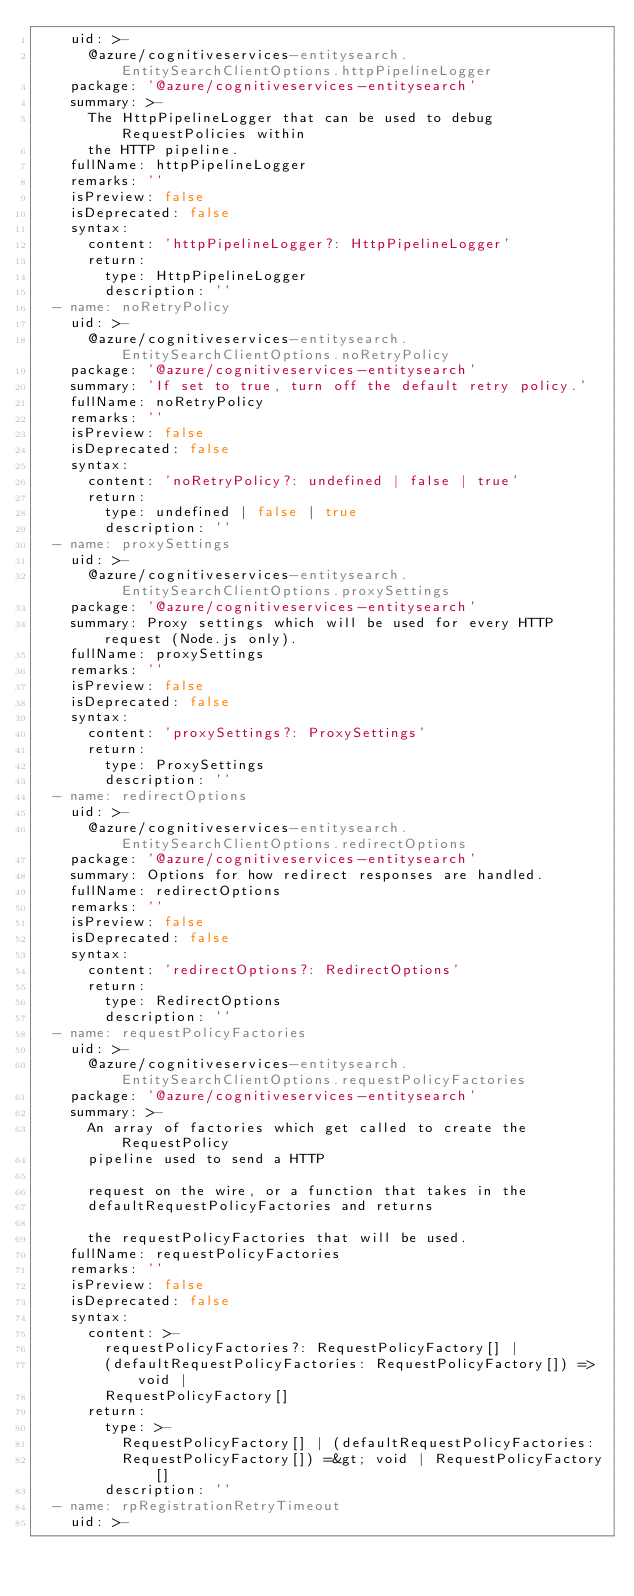<code> <loc_0><loc_0><loc_500><loc_500><_YAML_>    uid: >-
      @azure/cognitiveservices-entitysearch.EntitySearchClientOptions.httpPipelineLogger
    package: '@azure/cognitiveservices-entitysearch'
    summary: >-
      The HttpPipelineLogger that can be used to debug RequestPolicies within
      the HTTP pipeline.
    fullName: httpPipelineLogger
    remarks: ''
    isPreview: false
    isDeprecated: false
    syntax:
      content: 'httpPipelineLogger?: HttpPipelineLogger'
      return:
        type: HttpPipelineLogger
        description: ''
  - name: noRetryPolicy
    uid: >-
      @azure/cognitiveservices-entitysearch.EntitySearchClientOptions.noRetryPolicy
    package: '@azure/cognitiveservices-entitysearch'
    summary: 'If set to true, turn off the default retry policy.'
    fullName: noRetryPolicy
    remarks: ''
    isPreview: false
    isDeprecated: false
    syntax:
      content: 'noRetryPolicy?: undefined | false | true'
      return:
        type: undefined | false | true
        description: ''
  - name: proxySettings
    uid: >-
      @azure/cognitiveservices-entitysearch.EntitySearchClientOptions.proxySettings
    package: '@azure/cognitiveservices-entitysearch'
    summary: Proxy settings which will be used for every HTTP request (Node.js only).
    fullName: proxySettings
    remarks: ''
    isPreview: false
    isDeprecated: false
    syntax:
      content: 'proxySettings?: ProxySettings'
      return:
        type: ProxySettings
        description: ''
  - name: redirectOptions
    uid: >-
      @azure/cognitiveservices-entitysearch.EntitySearchClientOptions.redirectOptions
    package: '@azure/cognitiveservices-entitysearch'
    summary: Options for how redirect responses are handled.
    fullName: redirectOptions
    remarks: ''
    isPreview: false
    isDeprecated: false
    syntax:
      content: 'redirectOptions?: RedirectOptions'
      return:
        type: RedirectOptions
        description: ''
  - name: requestPolicyFactories
    uid: >-
      @azure/cognitiveservices-entitysearch.EntitySearchClientOptions.requestPolicyFactories
    package: '@azure/cognitiveservices-entitysearch'
    summary: >-
      An array of factories which get called to create the RequestPolicy
      pipeline used to send a HTTP

      request on the wire, or a function that takes in the
      defaultRequestPolicyFactories and returns

      the requestPolicyFactories that will be used.
    fullName: requestPolicyFactories
    remarks: ''
    isPreview: false
    isDeprecated: false
    syntax:
      content: >-
        requestPolicyFactories?: RequestPolicyFactory[] |
        (defaultRequestPolicyFactories: RequestPolicyFactory[]) => void |
        RequestPolicyFactory[]
      return:
        type: >-
          RequestPolicyFactory[] | (defaultRequestPolicyFactories:
          RequestPolicyFactory[]) =&gt; void | RequestPolicyFactory[]
        description: ''
  - name: rpRegistrationRetryTimeout
    uid: >-</code> 